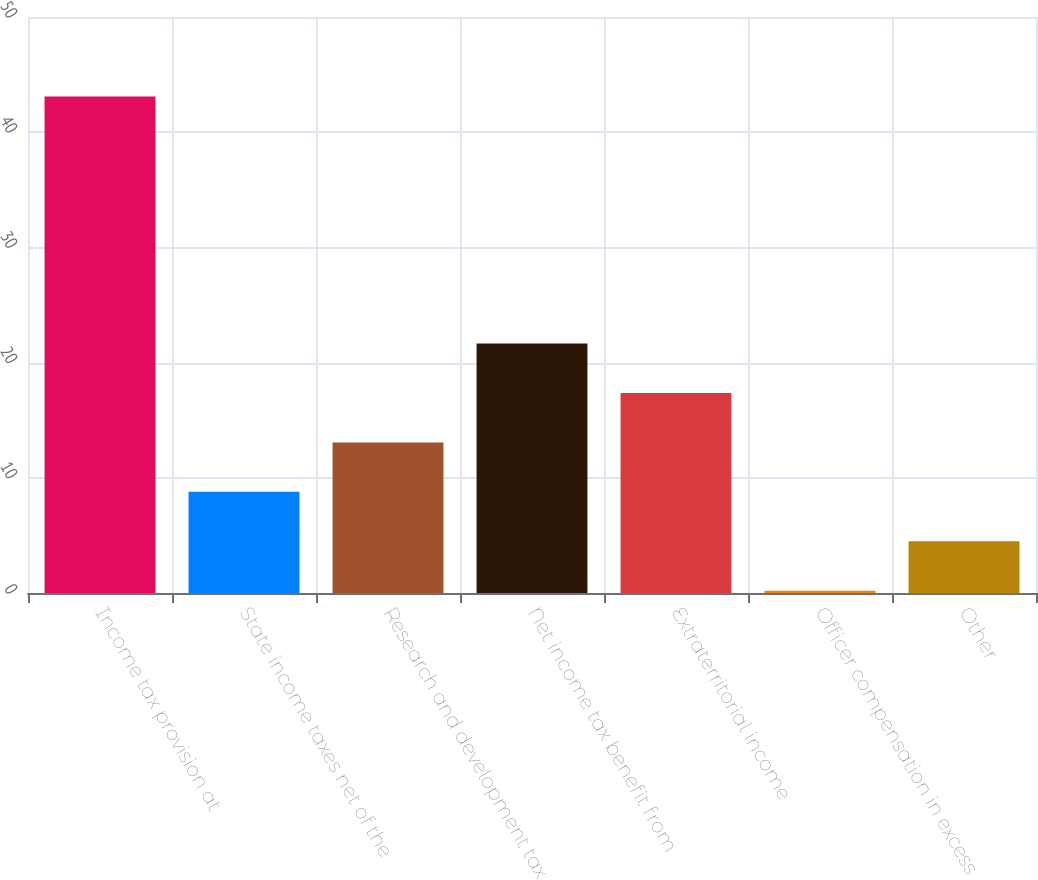Convert chart. <chart><loc_0><loc_0><loc_500><loc_500><bar_chart><fcel>Income tax provision at<fcel>State income taxes net of the<fcel>Research and development tax<fcel>Net income tax benefit from<fcel>Extraterritorial income<fcel>Officer compensation in excess<fcel>Other<nl><fcel>43.1<fcel>8.78<fcel>13.07<fcel>21.65<fcel>17.36<fcel>0.2<fcel>4.49<nl></chart> 